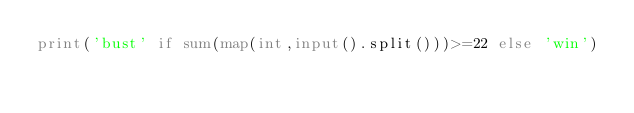Convert code to text. <code><loc_0><loc_0><loc_500><loc_500><_Python_>print('bust' if sum(map(int,input().split()))>=22 else 'win')</code> 